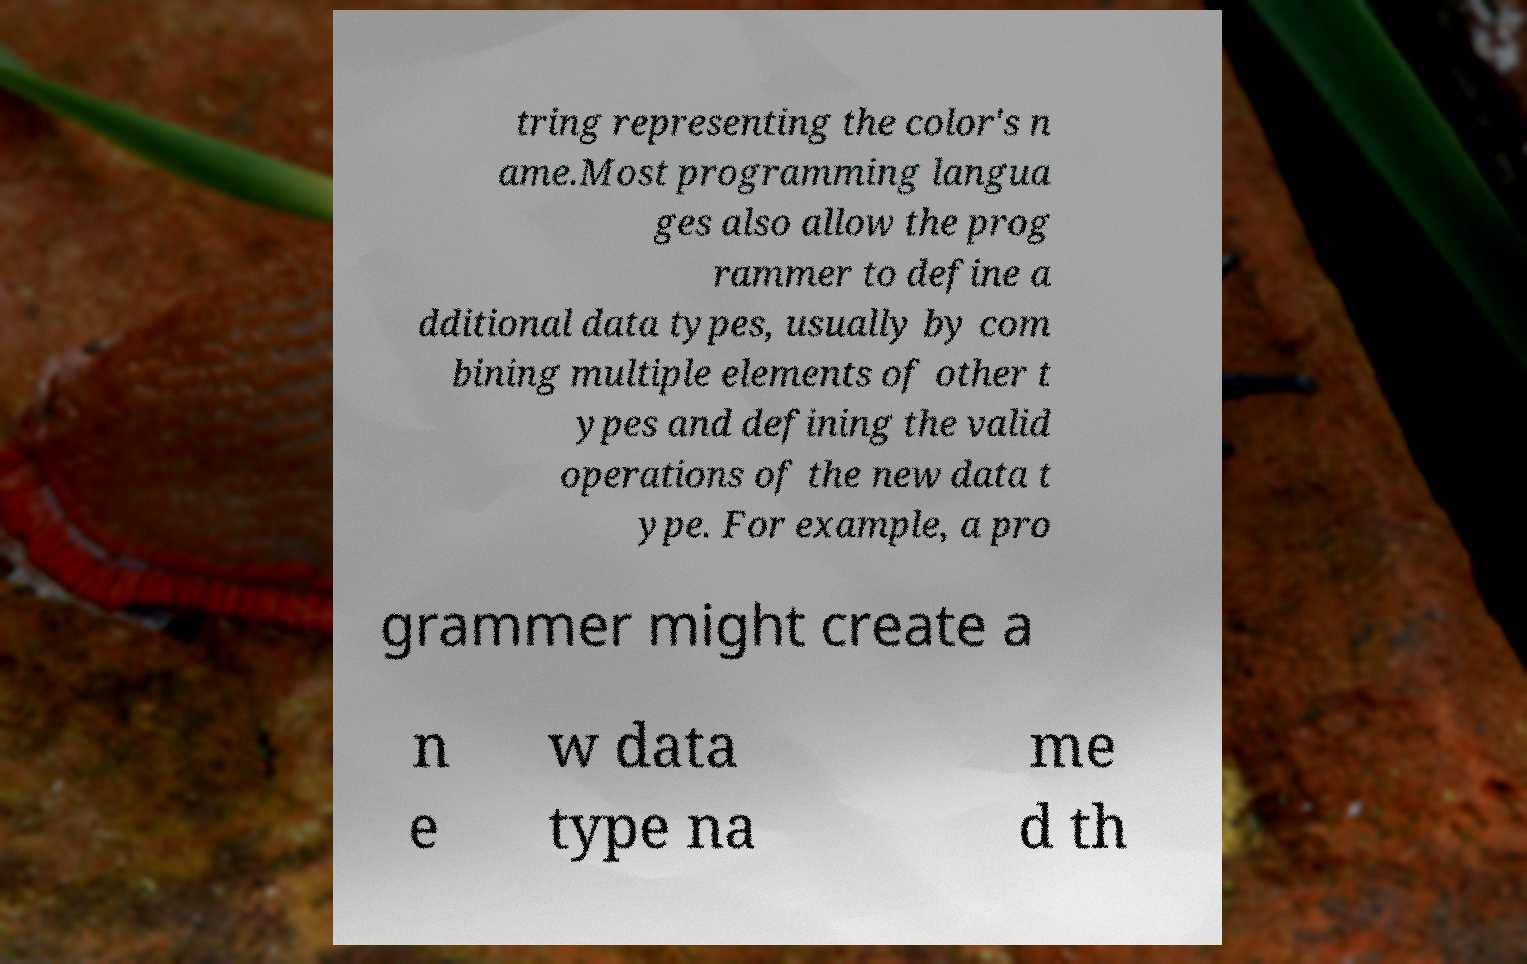There's text embedded in this image that I need extracted. Can you transcribe it verbatim? tring representing the color's n ame.Most programming langua ges also allow the prog rammer to define a dditional data types, usually by com bining multiple elements of other t ypes and defining the valid operations of the new data t ype. For example, a pro grammer might create a n e w data type na me d th 